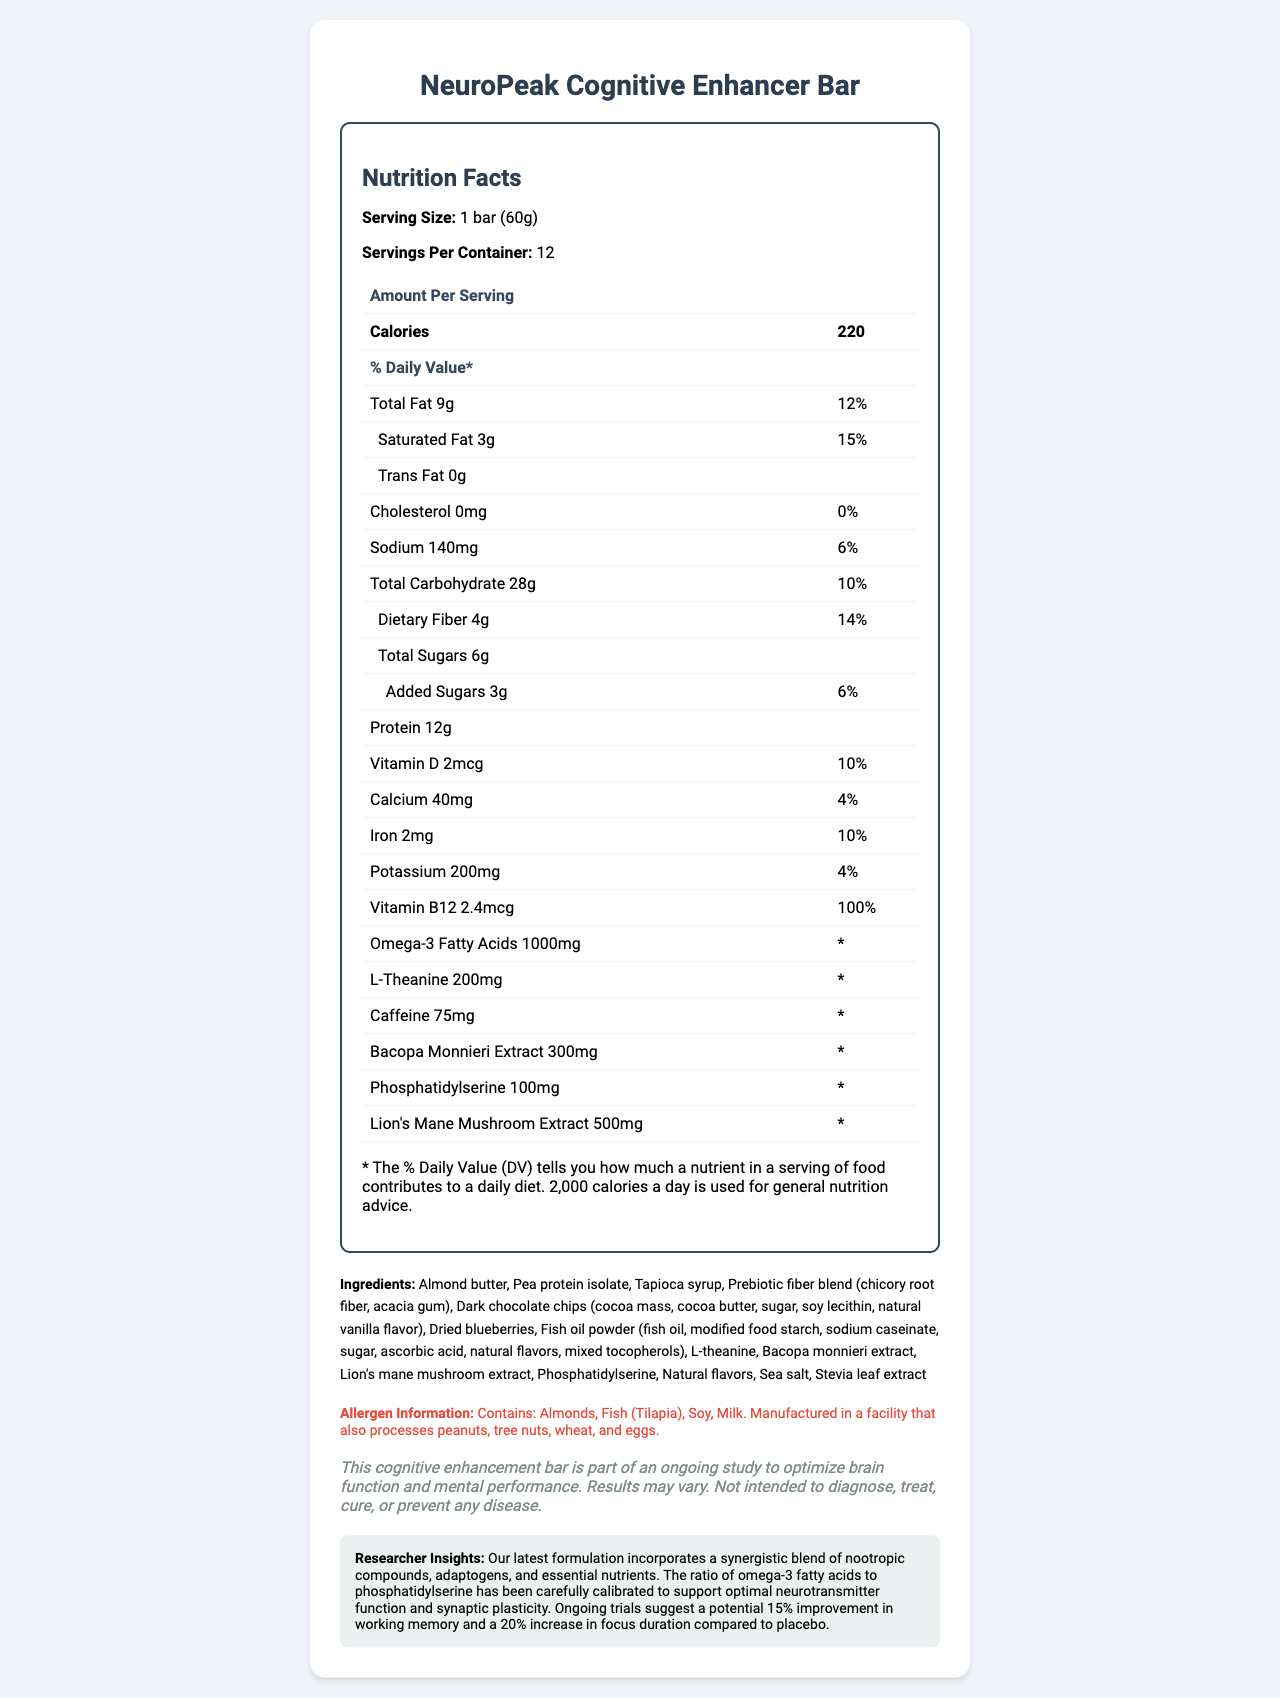who is the target audience for this product? The document mentions that the bar is part of an ongoing study to optimize brain function and mental performance.
Answer: Researchers and individuals interested in functional foods and cognitive enhancement what is the serving size of the NeuroPeak Cognitive Enhancer Bar? The nutrition facts section specifies that the serving size is 1 bar (60g).
Answer: 1 bar (60g) how many servings are there per container? The document clearly states there are 12 servings per container.
Answer: 12 how much protein does one serving of the bar provide? The nutrition facts state the amount of protein per serving is 12g.
Answer: 12g name one of the adaptogenic ingredients in this bar The document lists Bacopa monnieri extract as one of the ingredients.
Answer: Bacopa monnieri extract what is the percentage daily value of saturated fat per serving? The nutrition information lists saturated fat as having a daily value of 15%.
Answer: 15% are there any nuts in this bar? The allergen information specifies that the bar contains almonds.
Answer: Yes what is the main experimental focus of the NeuroPeak Cognitive Enhancer Bar? The experimental note highlights that the bar is part of a study to optimize brain function and mental performance.
Answer: To optimize brain function and mental performance which of the following is NOT an ingredient in the bar? A. Almond butter B. Fish oil powder C. Peanut butter D. Stevia leaf extract Peanut butter is not listed among the ingredients; the other options are present.
Answer: C how much caffeine is in one serving of the bar? A. 50mg B. 75mg C. 100mg D. 125mg The nutrition facts specify that one serving contains 75mg of caffeine.
Answer: B does the product contain any added sugar? Yes/No The nutrition facts detail that the product contains 3g of added sugars.
Answer: Yes summarize the nutrition and functional data presented in the document The document provides a balanced overview of the bar's nutritional content, functional ingredients, and potential cognitive benefits, all situated within the context of ongoing scientific research.
Answer: The NeuroPeak Cognitive Enhancer Bar is a functional food designed to optimize cognitive performance, providing 220 calories per serving with 12g of protein, significant amounts of omega-3 fatty acids, adaptogens, and nootropic compounds. It incorporates various ingredients to support brain health, while also paying attention to essential vitamins and minerals. Allergens include almonds, fish, soy, and milk. The document also highlights the bar's involvement in a study on mental performance enhancement. what are the potential cognitive benefits of the bar according to the researcher insights? The researcher insights mention ongoing trials suggesting these specific cognitive improvements compared to placebo.
Answer: 15% improvement in working memory and 20% increase in focus duration does the bar contain ingredients derived from fish? The ingredient list includes fish oil powder derived from tilapia.
Answer: Yes which nutrient in the bar contributes 100% of the daily value? The nutrition facts list vitamin B12 with a daily value of 100%.
Answer: Vitamin B12 how should the product be stored for maximum potency? The storage instructions specify that refrigeration after opening ensures maximum potency.
Answer: Refrigerate after opening is this bar intended to diagnose, treat, cure, or prevent any disease? The experimental note clearly states that the product is not intended to diagnose, treat, cure, or prevent any disease.
Answer: No where is the product manufactured? The document does not provide information about the manufacturing location.
Answer: Not enough information 